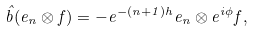Convert formula to latex. <formula><loc_0><loc_0><loc_500><loc_500>\hat { b } ( e _ { n } \otimes f ) = - e ^ { - ( n + 1 ) h } e _ { n } \otimes e ^ { i \phi } f ,</formula> 